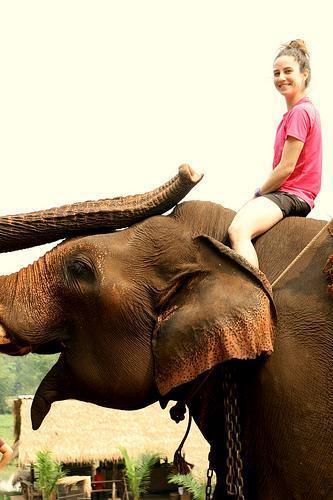How many elephants are shown?
Give a very brief answer. 1. 